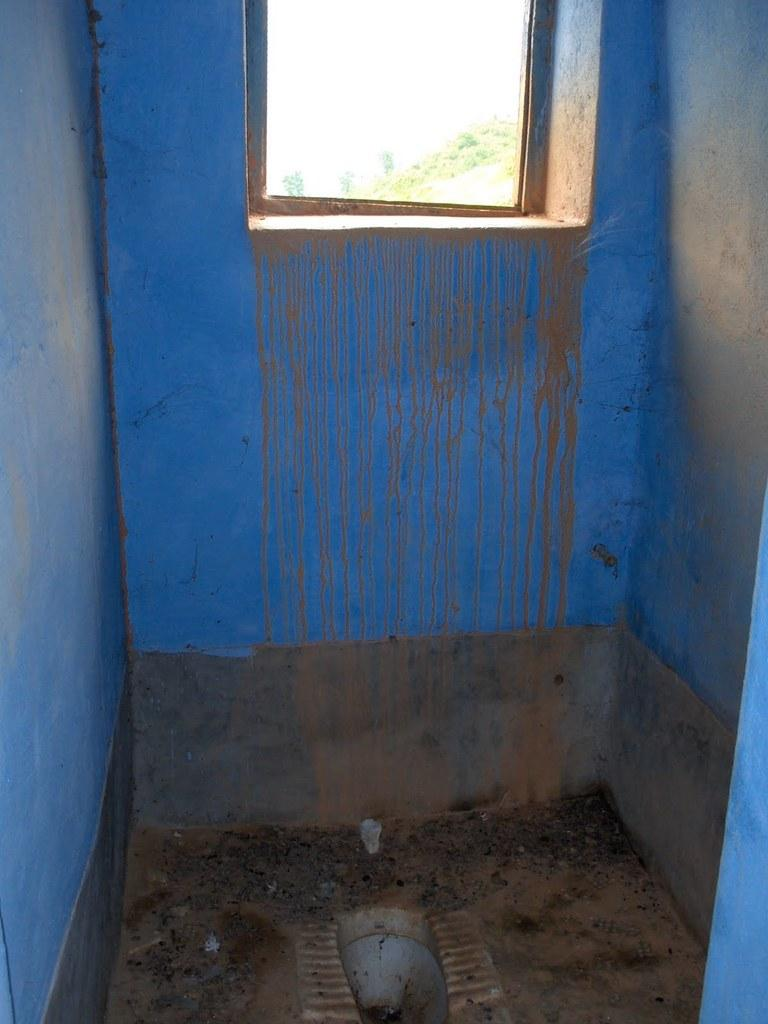What type of room is the image taken in? The image is taken in a bathroom. What fixture is located at the bottom of the image? There is a toilet at the bottom of the image. What can be seen in the background of the image? There is a wall and a window visible in the background of the image. What type of question is being asked in the image? There is no question being asked in the image; it is a still photograph of a bathroom. Is there any beef or popcorn visible in the image? No, there is no beef or popcorn present in the image. 